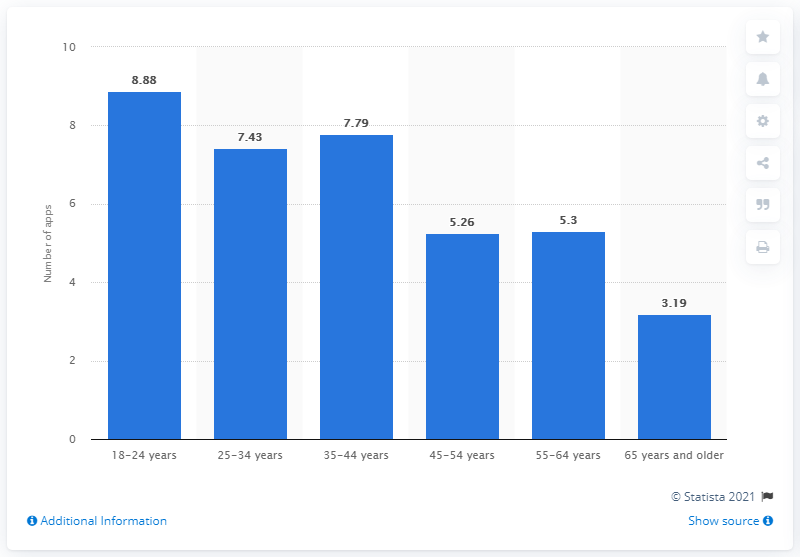List a handful of essential elements in this visual. In the month preceding the survey, the average number of apps used by Canadian smartphone users between the ages of 18 and 24 was 8.88. 